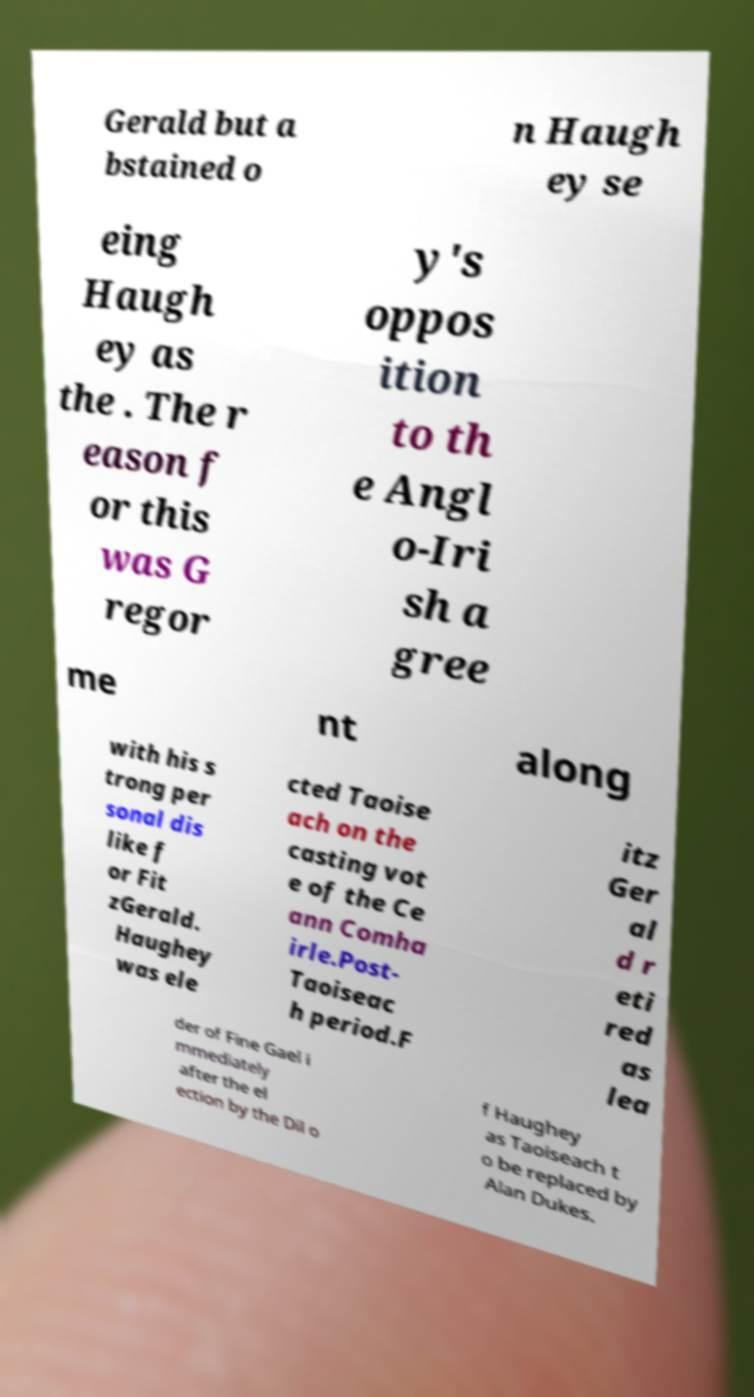There's text embedded in this image that I need extracted. Can you transcribe it verbatim? Gerald but a bstained o n Haugh ey se eing Haugh ey as the . The r eason f or this was G regor y's oppos ition to th e Angl o-Iri sh a gree me nt along with his s trong per sonal dis like f or Fit zGerald. Haughey was ele cted Taoise ach on the casting vot e of the Ce ann Comha irle.Post- Taoiseac h period.F itz Ger al d r eti red as lea der of Fine Gael i mmediately after the el ection by the Dil o f Haughey as Taoiseach t o be replaced by Alan Dukes. 